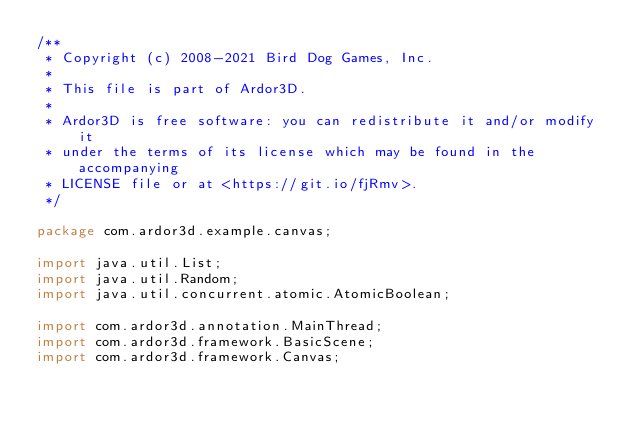<code> <loc_0><loc_0><loc_500><loc_500><_Java_>/**
 * Copyright (c) 2008-2021 Bird Dog Games, Inc.
 *
 * This file is part of Ardor3D.
 *
 * Ardor3D is free software: you can redistribute it and/or modify it
 * under the terms of its license which may be found in the accompanying
 * LICENSE file or at <https://git.io/fjRmv>.
 */

package com.ardor3d.example.canvas;

import java.util.List;
import java.util.Random;
import java.util.concurrent.atomic.AtomicBoolean;

import com.ardor3d.annotation.MainThread;
import com.ardor3d.framework.BasicScene;
import com.ardor3d.framework.Canvas;</code> 